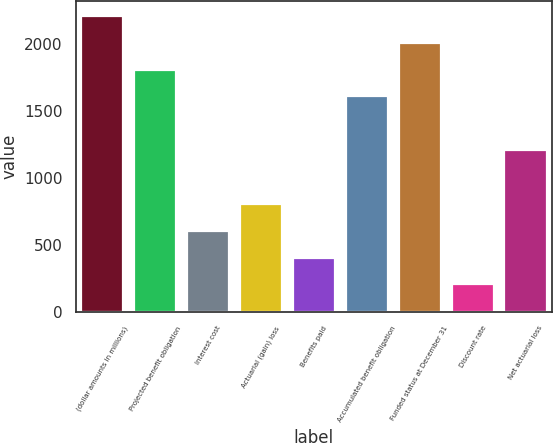Convert chart. <chart><loc_0><loc_0><loc_500><loc_500><bar_chart><fcel>(dollar amounts in millions)<fcel>Projected benefit obligation<fcel>Interest cost<fcel>Actuarial (gain) loss<fcel>Benefits paid<fcel>Accumulated benefit obligation<fcel>Funded status at December 31<fcel>Discount rate<fcel>Net actuarial loss<nl><fcel>2211.7<fcel>1810.3<fcel>606.1<fcel>806.8<fcel>405.4<fcel>1609.6<fcel>2011<fcel>204.7<fcel>1208.2<nl></chart> 